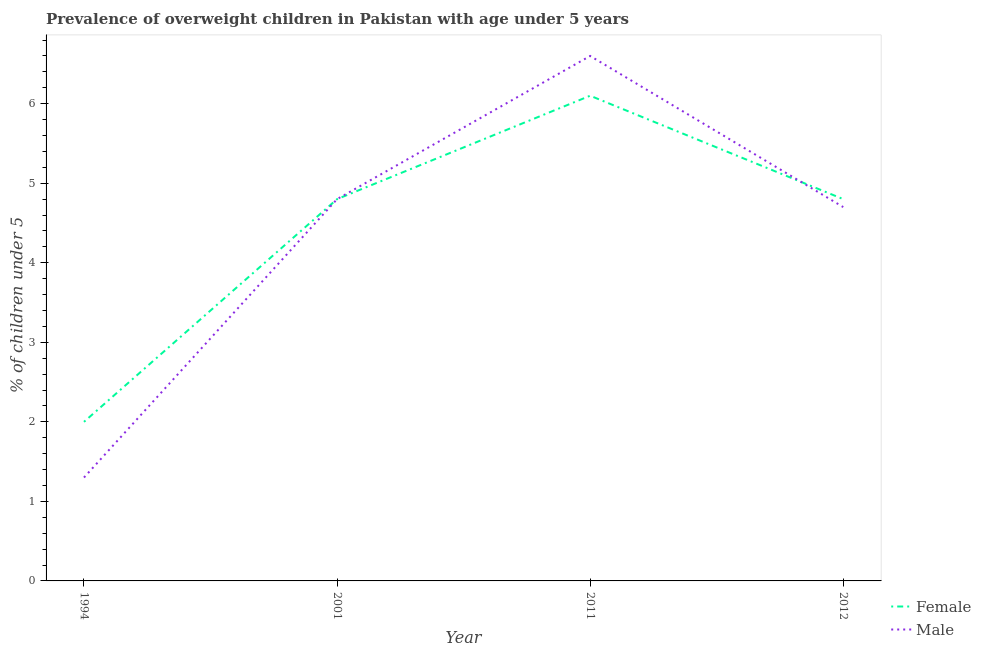How many different coloured lines are there?
Offer a very short reply. 2. Is the number of lines equal to the number of legend labels?
Your answer should be compact. Yes. What is the percentage of obese male children in 1994?
Your answer should be very brief. 1.3. Across all years, what is the maximum percentage of obese male children?
Give a very brief answer. 6.6. Across all years, what is the minimum percentage of obese female children?
Ensure brevity in your answer.  2. What is the total percentage of obese female children in the graph?
Provide a succinct answer. 17.7. What is the difference between the percentage of obese female children in 2001 and that in 2011?
Your answer should be very brief. -1.3. What is the difference between the percentage of obese female children in 2011 and the percentage of obese male children in 2001?
Your answer should be very brief. 1.3. What is the average percentage of obese female children per year?
Your answer should be very brief. 4.43. In how many years, is the percentage of obese female children greater than 3.2 %?
Offer a terse response. 3. What is the ratio of the percentage of obese female children in 2001 to that in 2012?
Provide a short and direct response. 1. Is the difference between the percentage of obese male children in 1994 and 2012 greater than the difference between the percentage of obese female children in 1994 and 2012?
Offer a very short reply. No. What is the difference between the highest and the second highest percentage of obese male children?
Your response must be concise. 1.8. What is the difference between the highest and the lowest percentage of obese female children?
Provide a succinct answer. 4.1. Does the percentage of obese male children monotonically increase over the years?
Your answer should be compact. No. How many legend labels are there?
Offer a terse response. 2. How are the legend labels stacked?
Keep it short and to the point. Vertical. What is the title of the graph?
Ensure brevity in your answer.  Prevalence of overweight children in Pakistan with age under 5 years. What is the label or title of the Y-axis?
Keep it short and to the point.  % of children under 5. What is the  % of children under 5 of Female in 1994?
Provide a succinct answer. 2. What is the  % of children under 5 of Male in 1994?
Give a very brief answer. 1.3. What is the  % of children under 5 in Female in 2001?
Give a very brief answer. 4.8. What is the  % of children under 5 of Male in 2001?
Your answer should be compact. 4.8. What is the  % of children under 5 of Female in 2011?
Offer a very short reply. 6.1. What is the  % of children under 5 in Male in 2011?
Provide a short and direct response. 6.6. What is the  % of children under 5 in Female in 2012?
Your answer should be compact. 4.8. What is the  % of children under 5 in Male in 2012?
Ensure brevity in your answer.  4.7. Across all years, what is the maximum  % of children under 5 of Female?
Keep it short and to the point. 6.1. Across all years, what is the maximum  % of children under 5 in Male?
Provide a short and direct response. 6.6. Across all years, what is the minimum  % of children under 5 in Male?
Keep it short and to the point. 1.3. What is the difference between the  % of children under 5 in Female in 1994 and that in 2001?
Offer a very short reply. -2.8. What is the difference between the  % of children under 5 in Female in 1994 and that in 2011?
Your answer should be compact. -4.1. What is the difference between the  % of children under 5 of Male in 1994 and that in 2012?
Provide a short and direct response. -3.4. What is the difference between the  % of children under 5 of Female in 2001 and that in 2011?
Offer a very short reply. -1.3. What is the difference between the  % of children under 5 of Male in 2001 and that in 2011?
Provide a short and direct response. -1.8. What is the difference between the  % of children under 5 of Male in 2001 and that in 2012?
Give a very brief answer. 0.1. What is the difference between the  % of children under 5 in Female in 2011 and that in 2012?
Offer a terse response. 1.3. What is the difference between the  % of children under 5 in Female in 1994 and the  % of children under 5 in Male in 2001?
Your answer should be very brief. -2.8. What is the difference between the  % of children under 5 of Female in 1994 and the  % of children under 5 of Male in 2011?
Ensure brevity in your answer.  -4.6. What is the average  % of children under 5 of Female per year?
Make the answer very short. 4.42. What is the average  % of children under 5 in Male per year?
Your answer should be very brief. 4.35. In the year 2001, what is the difference between the  % of children under 5 in Female and  % of children under 5 in Male?
Provide a succinct answer. 0. In the year 2011, what is the difference between the  % of children under 5 of Female and  % of children under 5 of Male?
Make the answer very short. -0.5. What is the ratio of the  % of children under 5 in Female in 1994 to that in 2001?
Your answer should be very brief. 0.42. What is the ratio of the  % of children under 5 of Male in 1994 to that in 2001?
Offer a very short reply. 0.27. What is the ratio of the  % of children under 5 in Female in 1994 to that in 2011?
Offer a very short reply. 0.33. What is the ratio of the  % of children under 5 of Male in 1994 to that in 2011?
Offer a very short reply. 0.2. What is the ratio of the  % of children under 5 in Female in 1994 to that in 2012?
Give a very brief answer. 0.42. What is the ratio of the  % of children under 5 of Male in 1994 to that in 2012?
Your answer should be compact. 0.28. What is the ratio of the  % of children under 5 of Female in 2001 to that in 2011?
Make the answer very short. 0.79. What is the ratio of the  % of children under 5 in Male in 2001 to that in 2011?
Offer a terse response. 0.73. What is the ratio of the  % of children under 5 of Male in 2001 to that in 2012?
Provide a short and direct response. 1.02. What is the ratio of the  % of children under 5 of Female in 2011 to that in 2012?
Your response must be concise. 1.27. What is the ratio of the  % of children under 5 in Male in 2011 to that in 2012?
Make the answer very short. 1.4. What is the difference between the highest and the second highest  % of children under 5 in Female?
Your answer should be compact. 1.3. What is the difference between the highest and the lowest  % of children under 5 of Female?
Ensure brevity in your answer.  4.1. 